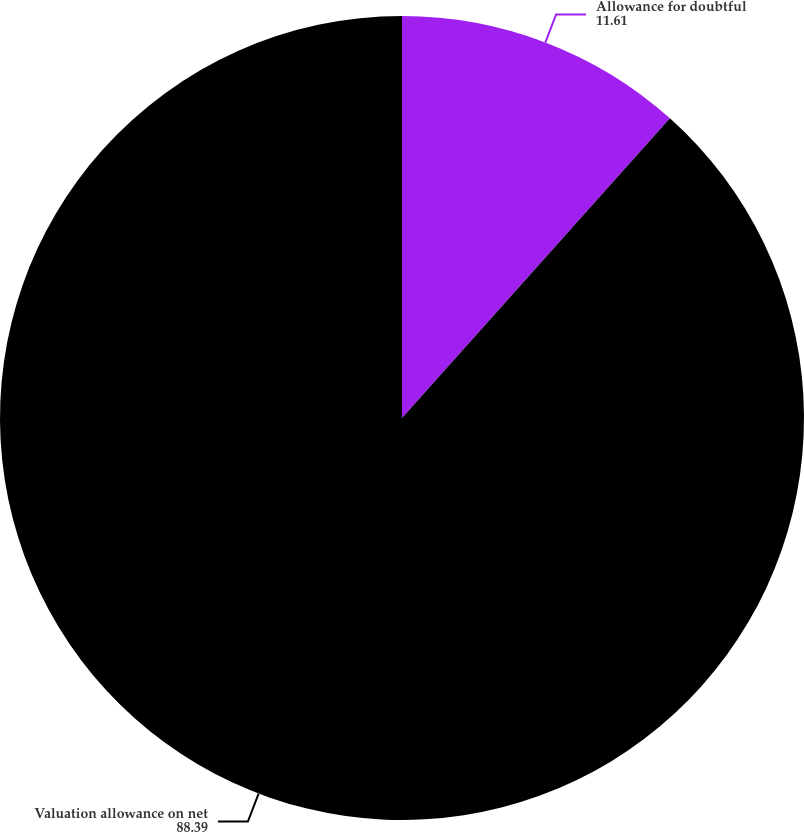Convert chart to OTSL. <chart><loc_0><loc_0><loc_500><loc_500><pie_chart><fcel>Allowance for doubtful<fcel>Valuation allowance on net<nl><fcel>11.61%<fcel>88.39%<nl></chart> 